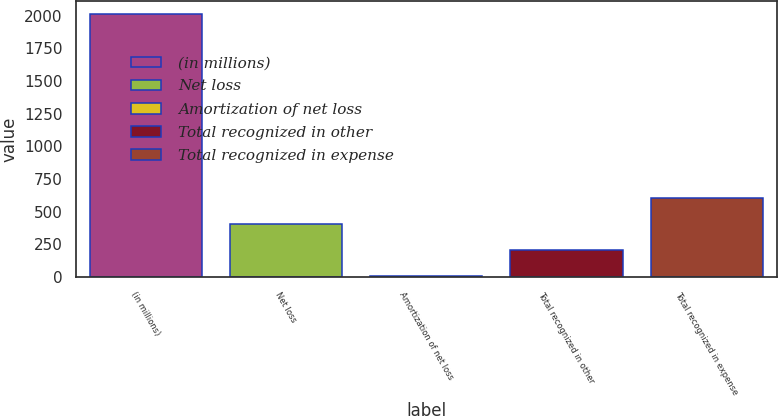Convert chart to OTSL. <chart><loc_0><loc_0><loc_500><loc_500><bar_chart><fcel>(in millions)<fcel>Net loss<fcel>Amortization of net loss<fcel>Total recognized in other<fcel>Total recognized in expense<nl><fcel>2010<fcel>405.2<fcel>4<fcel>204.6<fcel>605.8<nl></chart> 